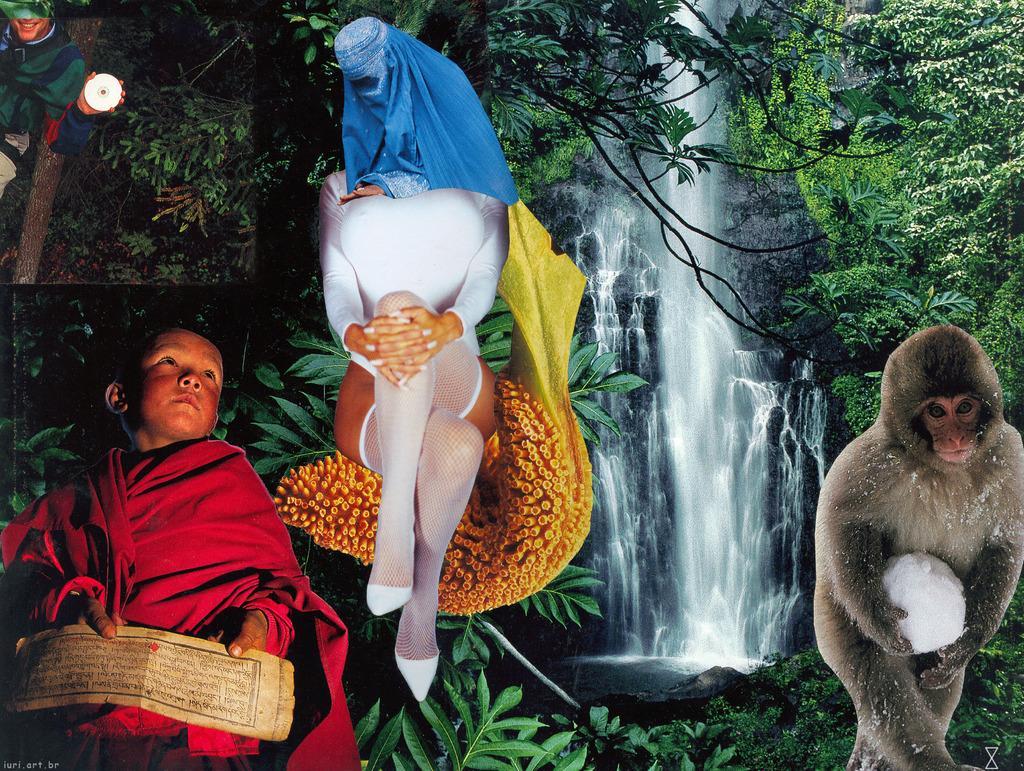Describe this image in one or two sentences. In the image we can see the image is a collage of pictures where in the corner there is a monkey holding the snowball, behind there is a waterfall and there are lot of trees. There is a person who is sitting and there is a scarf on the head. At the corner person is holding the CD and in the bottom person is holding a paper and he is wearing a red colour dress. 